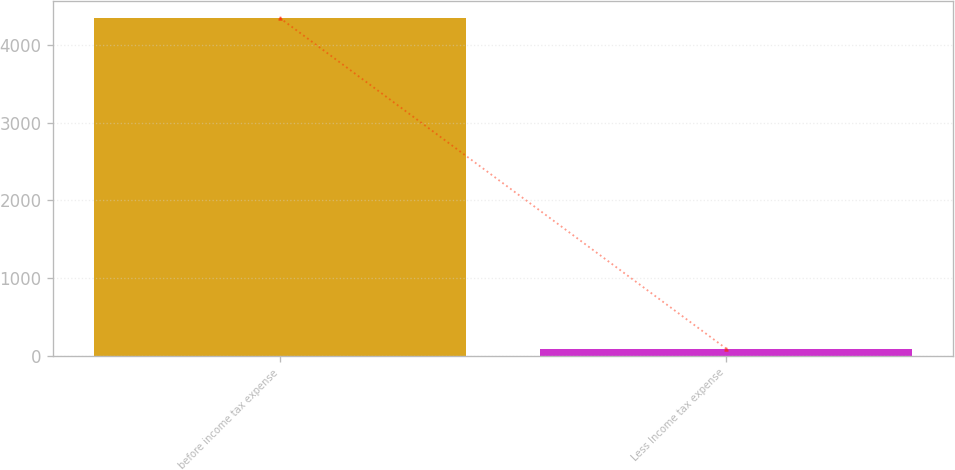<chart> <loc_0><loc_0><loc_500><loc_500><bar_chart><fcel>before income tax expense<fcel>Less Income tax expense<nl><fcel>4350<fcel>93<nl></chart> 